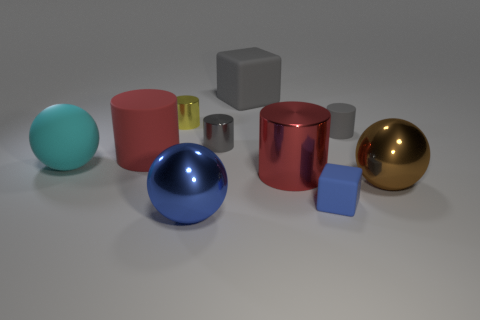There is a shiny ball that is the same color as the small block; what size is it?
Provide a short and direct response. Large. How many cylinders are small gray metal objects or tiny yellow shiny objects?
Offer a terse response. 2. There is a rubber cylinder to the right of the big cube; what is its color?
Ensure brevity in your answer.  Gray. The yellow shiny thing that is the same size as the blue matte cube is what shape?
Ensure brevity in your answer.  Cylinder. There is a large blue shiny object; how many large things are left of it?
Offer a very short reply. 2. What number of things are either brown shiny objects or big cylinders?
Offer a terse response. 3. What is the shape of the tiny thing that is behind the matte sphere and right of the big shiny cylinder?
Give a very brief answer. Cylinder. What number of gray shiny blocks are there?
Offer a terse response. 0. What color is the big cube that is made of the same material as the big cyan object?
Your response must be concise. Gray. Is the number of brown shiny things greater than the number of small blue metallic cubes?
Your answer should be compact. Yes. 